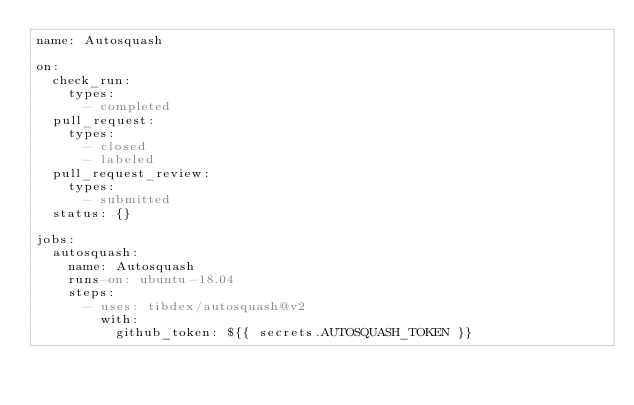<code> <loc_0><loc_0><loc_500><loc_500><_YAML_>name: Autosquash

on:
  check_run:
    types:
      - completed
  pull_request:
    types:
      - closed
      - labeled
  pull_request_review:
    types:
      - submitted
  status: {}

jobs:
  autosquash:
    name: Autosquash
    runs-on: ubuntu-18.04
    steps:
      - uses: tibdex/autosquash@v2
        with:
          github_token: ${{ secrets.AUTOSQUASH_TOKEN }}
</code> 